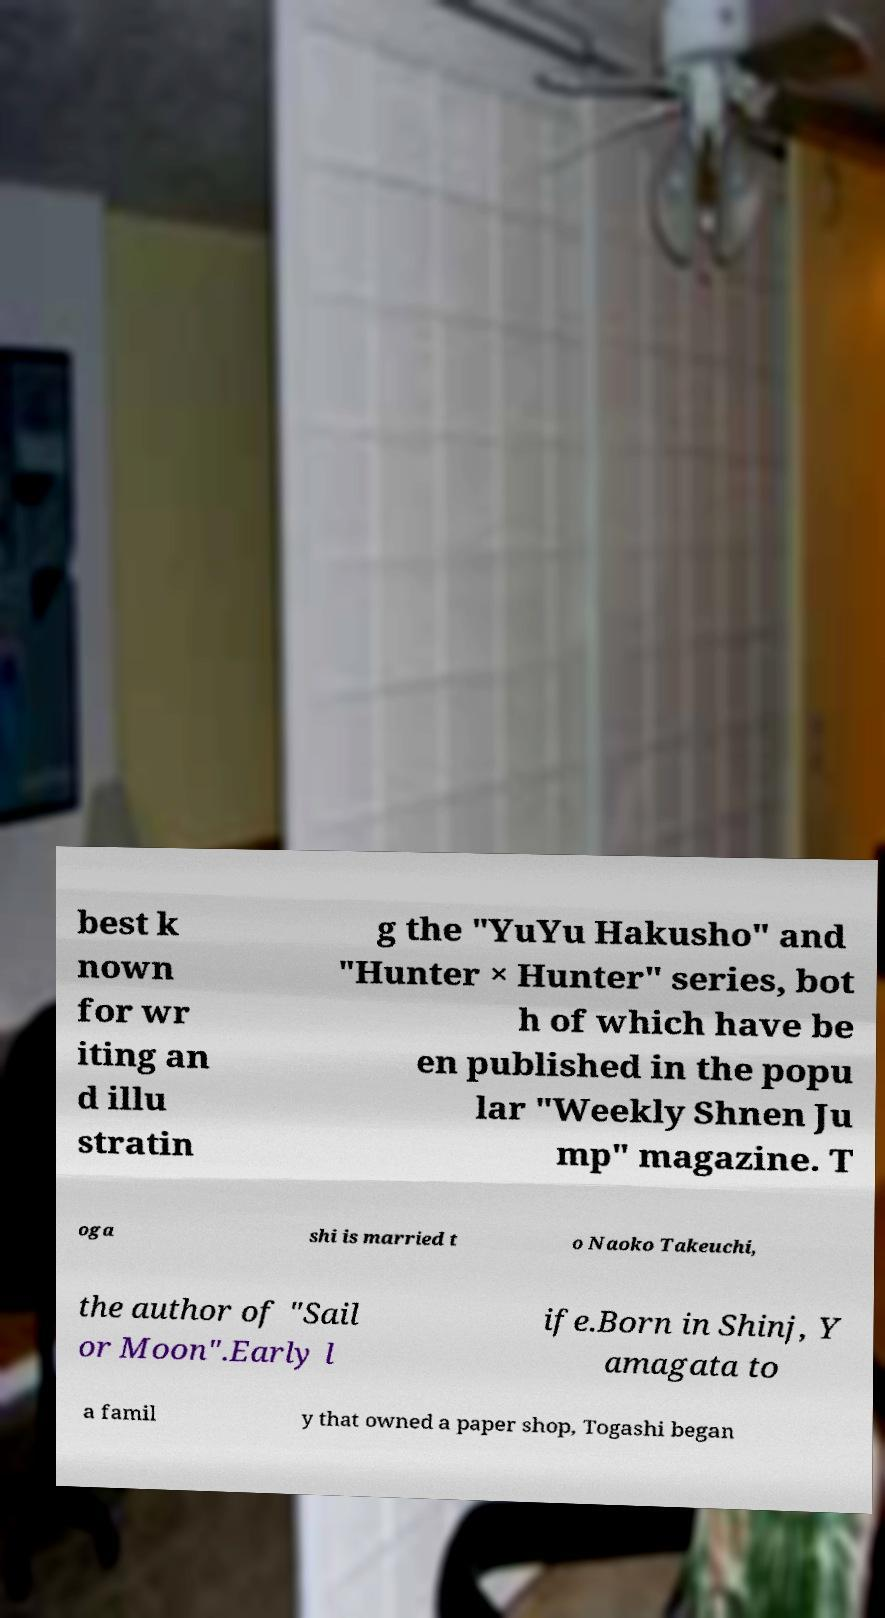I need the written content from this picture converted into text. Can you do that? best k nown for wr iting an d illu stratin g the "YuYu Hakusho" and "Hunter × Hunter" series, bot h of which have be en published in the popu lar "Weekly Shnen Ju mp" magazine. T oga shi is married t o Naoko Takeuchi, the author of "Sail or Moon".Early l ife.Born in Shinj, Y amagata to a famil y that owned a paper shop, Togashi began 